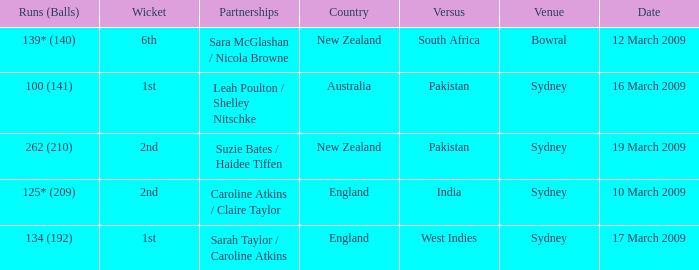What are the dates where the versus team is South Africa? 12 March 2009. 